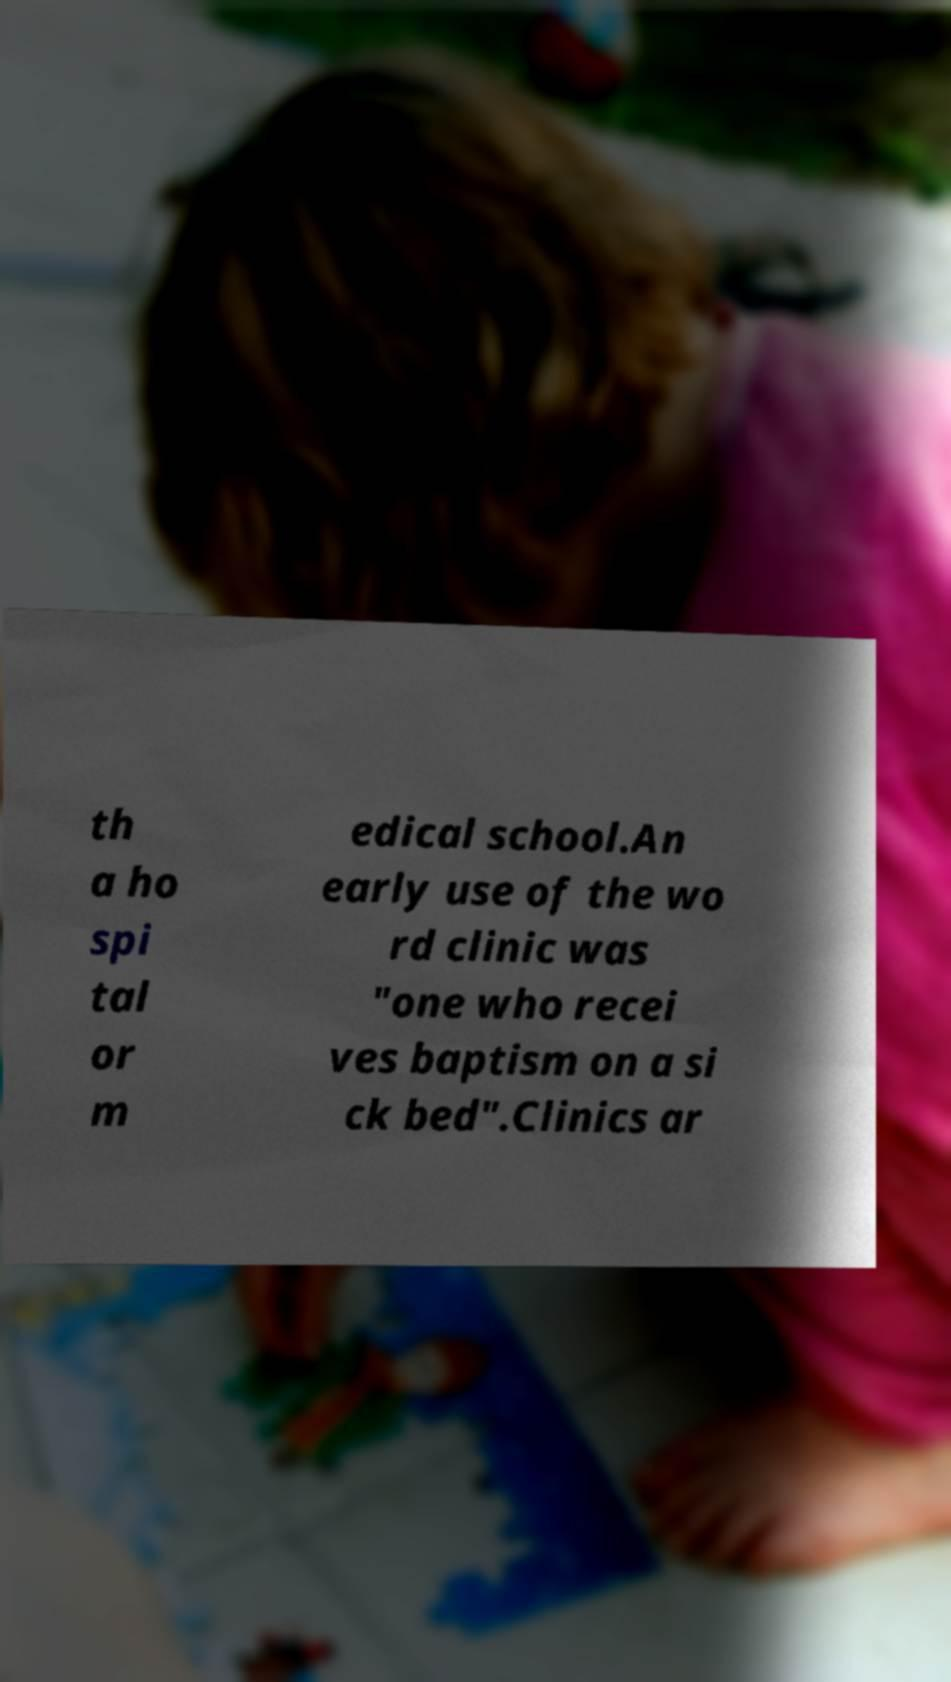Can you read and provide the text displayed in the image?This photo seems to have some interesting text. Can you extract and type it out for me? th a ho spi tal or m edical school.An early use of the wo rd clinic was "one who recei ves baptism on a si ck bed".Clinics ar 